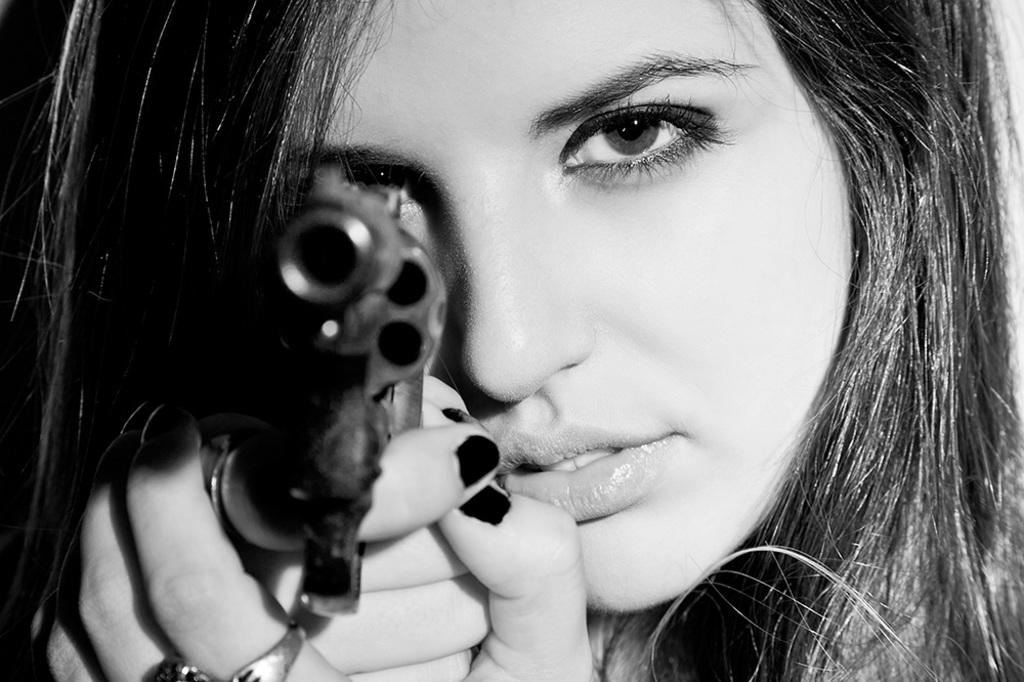What is the color scheme of the image? The picture is black and white. Who is present in the image? There is a woman in the image. What is the woman holding in the image? The woman is holding a gun. What type of toothbrush is the woman using in the image? There is no toothbrush present in the image; the woman is holding a gun. 